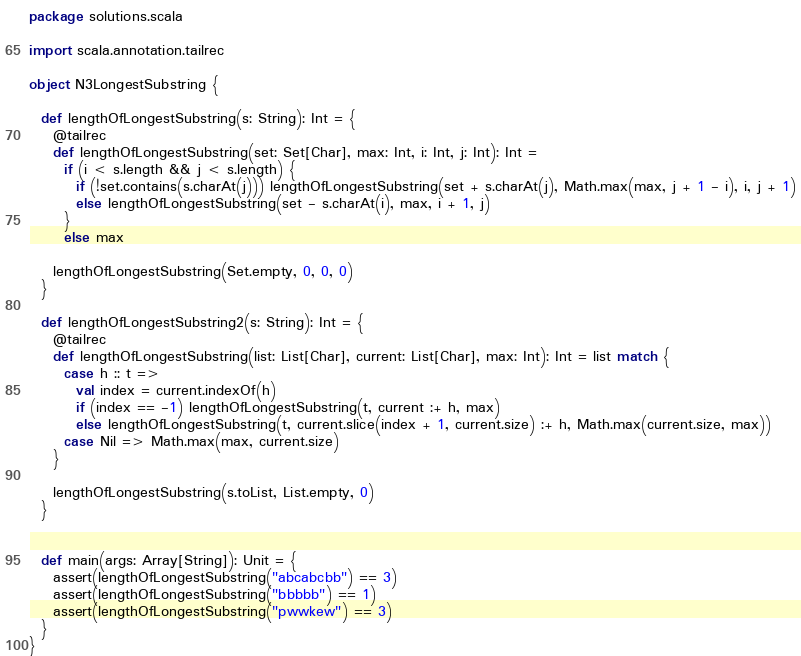Convert code to text. <code><loc_0><loc_0><loc_500><loc_500><_Scala_>package solutions.scala

import scala.annotation.tailrec

object N3LongestSubstring {

  def lengthOfLongestSubstring(s: String): Int = {
    @tailrec
    def lengthOfLongestSubstring(set: Set[Char], max: Int, i: Int, j: Int): Int =
      if (i < s.length && j < s.length) {
        if (!set.contains(s.charAt(j))) lengthOfLongestSubstring(set + s.charAt(j), Math.max(max, j + 1 - i), i, j + 1)
        else lengthOfLongestSubstring(set - s.charAt(i), max, i + 1, j)
      }
      else max

    lengthOfLongestSubstring(Set.empty, 0, 0, 0)
  }

  def lengthOfLongestSubstring2(s: String): Int = {
    @tailrec
    def lengthOfLongestSubstring(list: List[Char], current: List[Char], max: Int): Int = list match {
      case h :: t =>
        val index = current.indexOf(h)
        if (index == -1) lengthOfLongestSubstring(t, current :+ h, max)
        else lengthOfLongestSubstring(t, current.slice(index + 1, current.size) :+ h, Math.max(current.size, max))
      case Nil => Math.max(max, current.size)
    }

    lengthOfLongestSubstring(s.toList, List.empty, 0)
  }


  def main(args: Array[String]): Unit = {
    assert(lengthOfLongestSubstring("abcabcbb") == 3)
    assert(lengthOfLongestSubstring("bbbbb") == 1)
    assert(lengthOfLongestSubstring("pwwkew") == 3)
  }
}
</code> 